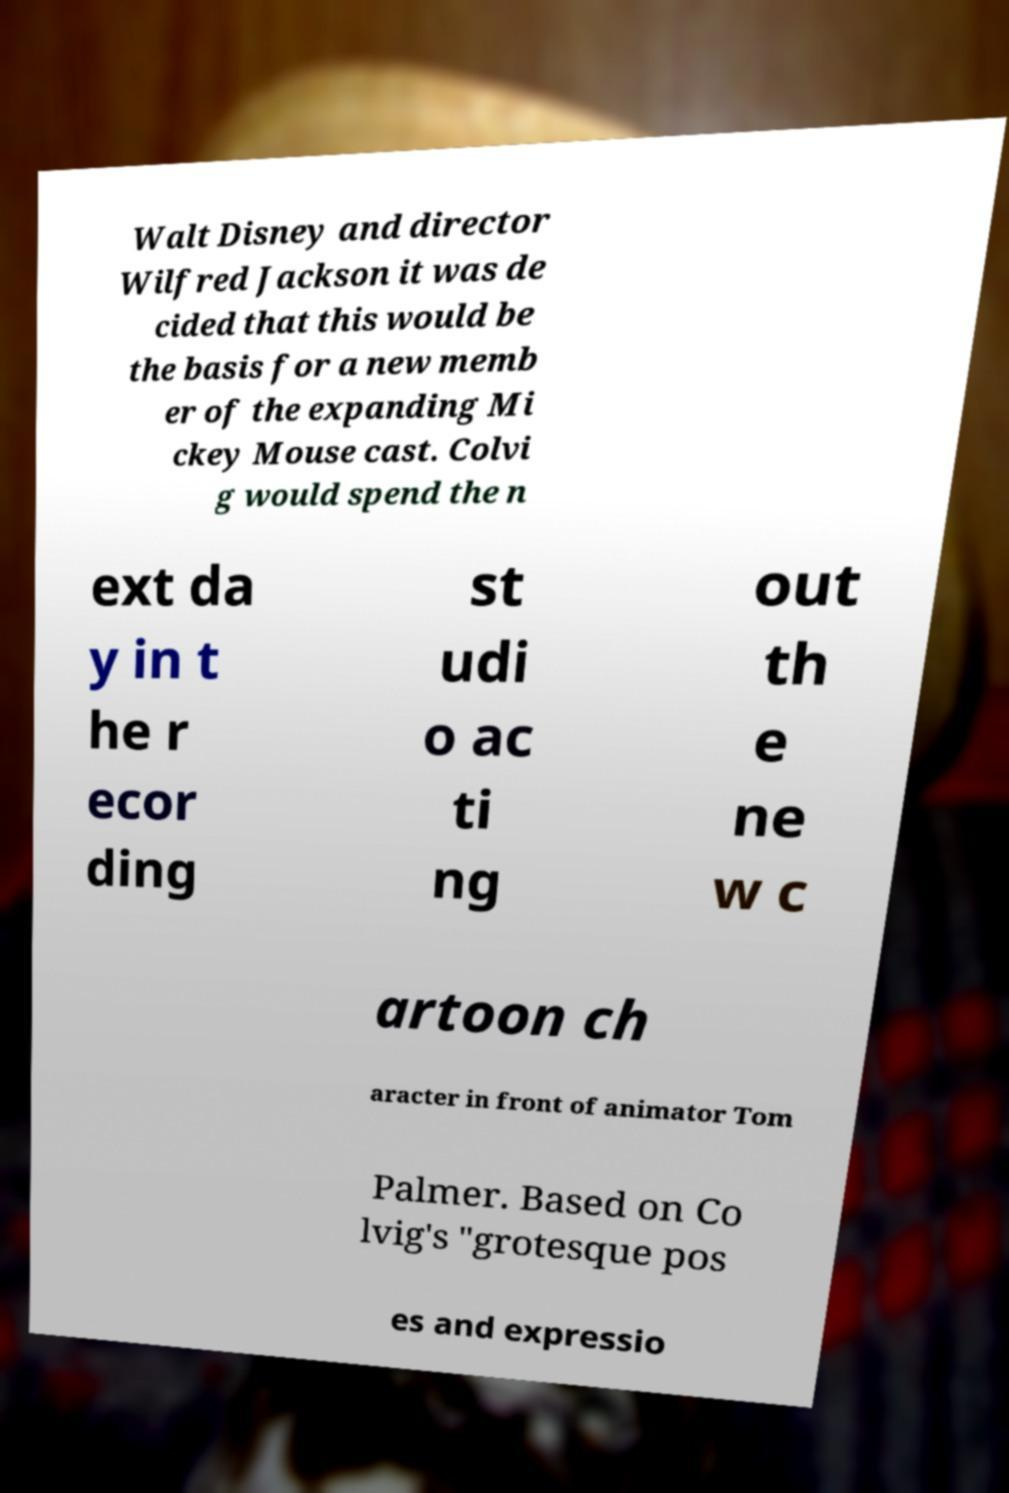Can you accurately transcribe the text from the provided image for me? Walt Disney and director Wilfred Jackson it was de cided that this would be the basis for a new memb er of the expanding Mi ckey Mouse cast. Colvi g would spend the n ext da y in t he r ecor ding st udi o ac ti ng out th e ne w c artoon ch aracter in front of animator Tom Palmer. Based on Co lvig's "grotesque pos es and expressio 